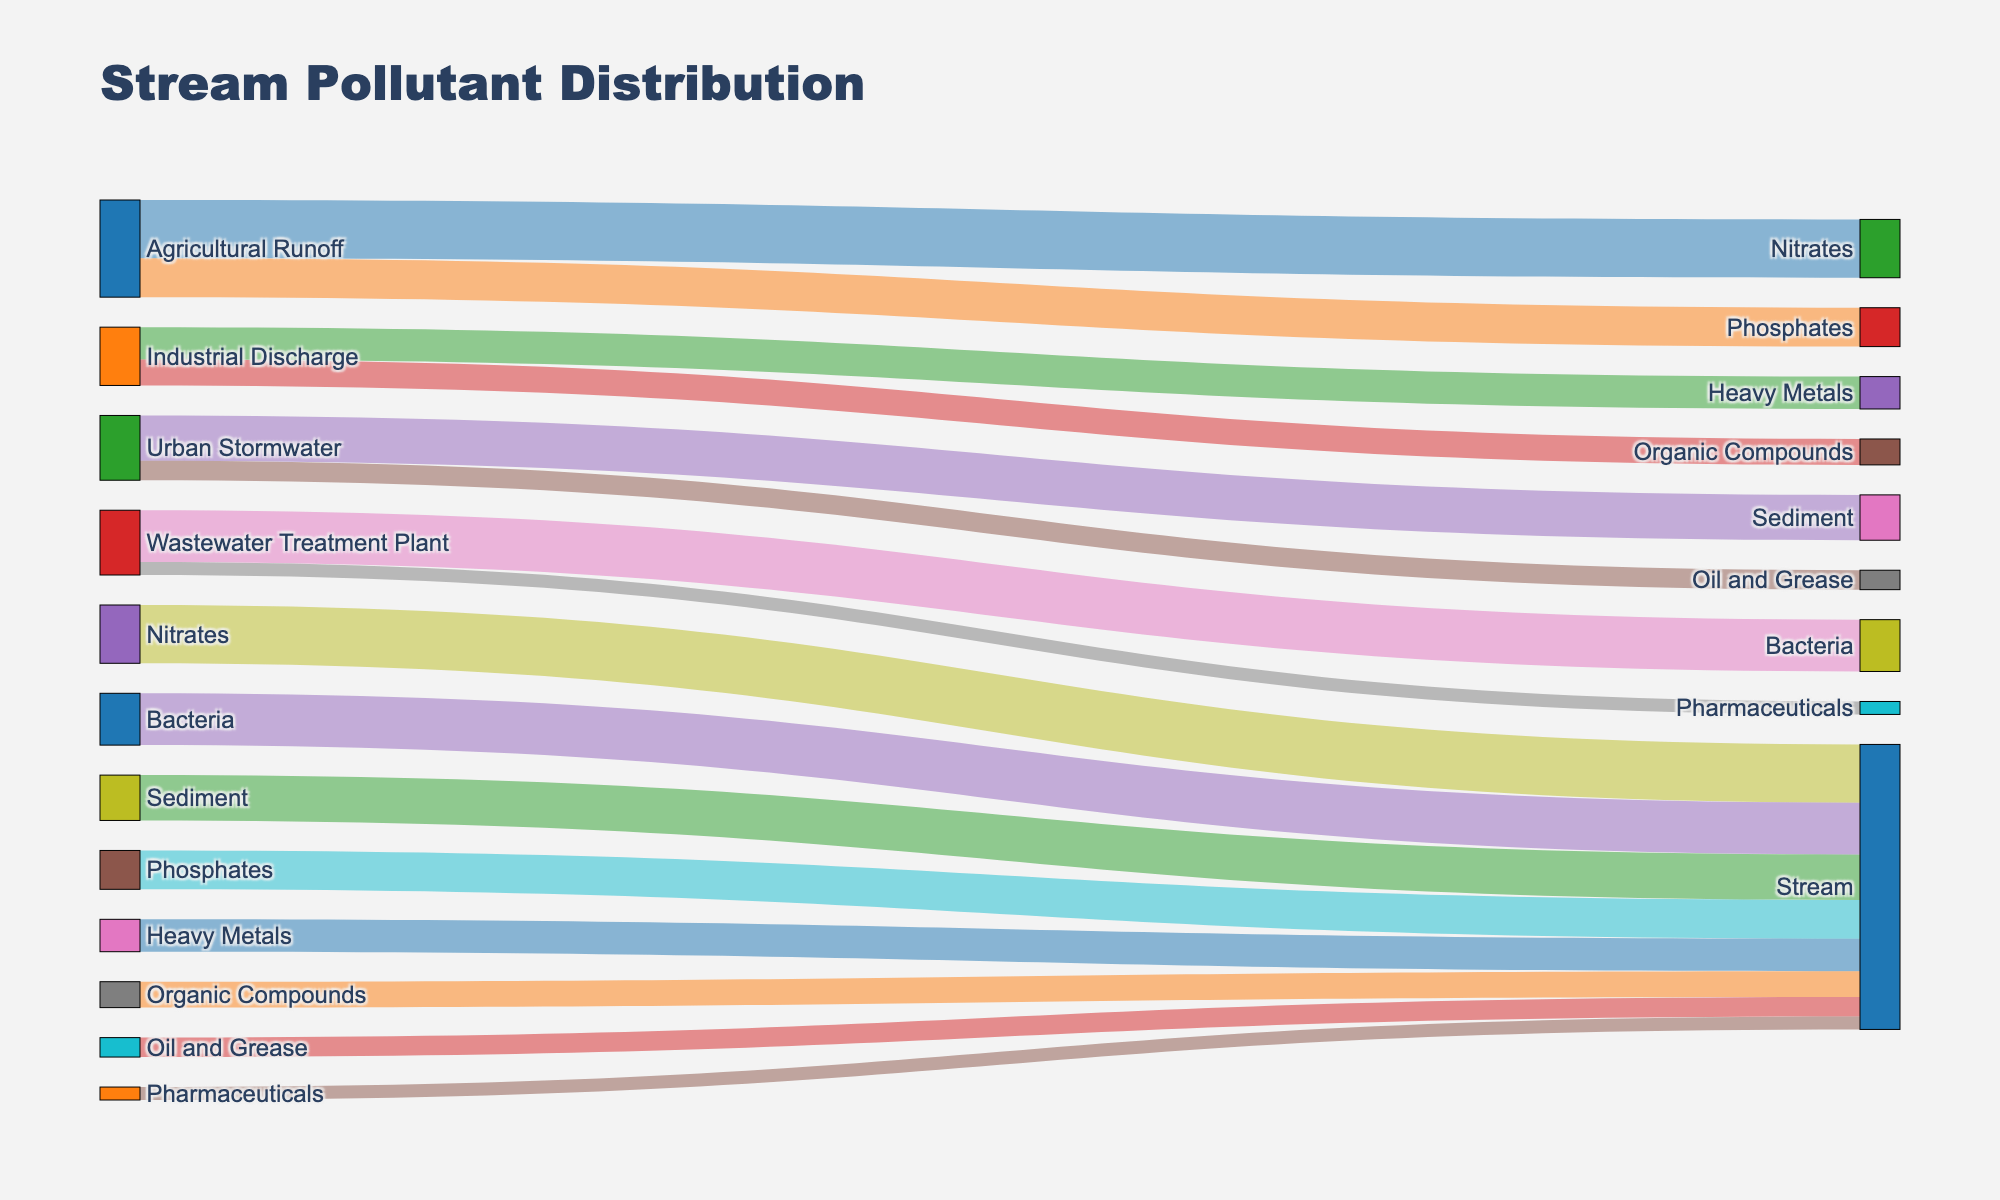what is the title of the diagram? The diagram has a prominent title at the top, which reads "Stream Pollutant Distribution". This title provides an overall context for the contents of the diagram, which shows how pollutants are distributed in the stream from various sources.
Answer: Stream Pollutant Distribution What pollutant has the highest contribution from Agricultural Runoff? By looking at the Sankey diagram, we can see that the contributions from Agricultural Runoff split into Nitrates and Phosphates. The diagram shows that Nitrates have a value of 45, whereas Phosphates have a value of 30. Therefore, Nitrates has the highest contribution from Agricultural Runoff.
Answer: Nitrates Which source has the highest number of pollutants flowing into the stream? The sources listed are Agricultural Runoff, Industrial Discharge, Urban Stormwater, and Wastewater Treatment Plant. To find the highest number of pollutants, we count the number of connections from each source. Agricultural Runoff has 2, Industrial Discharge has 2, Urban Stormwater has 2, and Wastewater Treatment Plant has 2. As they all have the same number, there's no single source with the highest number.
Answer: All have same number (2) What is the total amount of pollutants entering the stream from Urban Stormwater? Urban Stormwater contributions split into Sediment and Oil and Grease. Sediment has a value of 35, and Oil and Grease have a value of 15. To find the total, we add these values together: 35 + 15 = 50.
Answer: 50 Which pollutant flows exclusively from a single source? In the diagram, every pollutant has a source, and we need to check if any of them come from only one source. Nitrates, Phosphates, Heavy Metals, Organic Compounds, Sediment, Oil and Grease, Bacteria, and Pharmaceuticals all come from one source only.
Answer: All Among the pollutants, which has the lowest contribution to the stream? We examine all the values of pollutants flowing into the stream: Nitrates (45), Phosphates (30), Heavy Metals (25), Organic Compounds (20), Sediment (35), Oil and Grease (15), Bacteria (40), and Pharmaceuticals (10). The lowest value is 10, which is for Pharmaceuticals.
Answer: Pharmaceuticals What is the sum of values for pollutants from Wastewater Treatment Plant? Wastewater Treatment Plant splits into Bacteria and Pharmaceuticals with values of 40 and 10 respectively. Adding them together gives: 40 + 10 = 50.
Answer: 50 From which source does Oil and Grease originate? The diagram shows that Oil and Grease come from one source, Urban Stormwater. This is indicated by a direct link from Urban Stormwater to Oil and Grease.
Answer: Urban Stormwater 